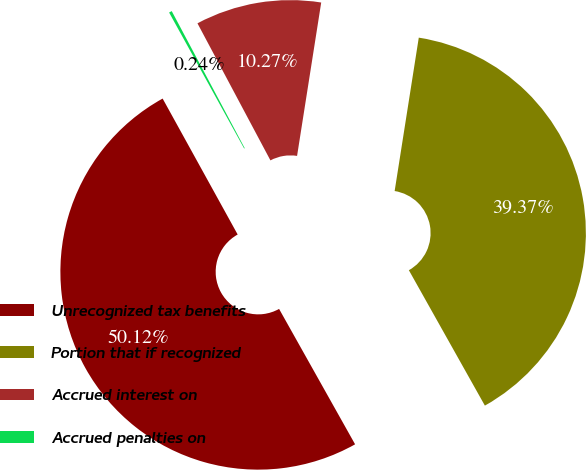<chart> <loc_0><loc_0><loc_500><loc_500><pie_chart><fcel>Unrecognized tax benefits<fcel>Portion that if recognized<fcel>Accrued interest on<fcel>Accrued penalties on<nl><fcel>50.11%<fcel>39.37%<fcel>10.27%<fcel>0.24%<nl></chart> 